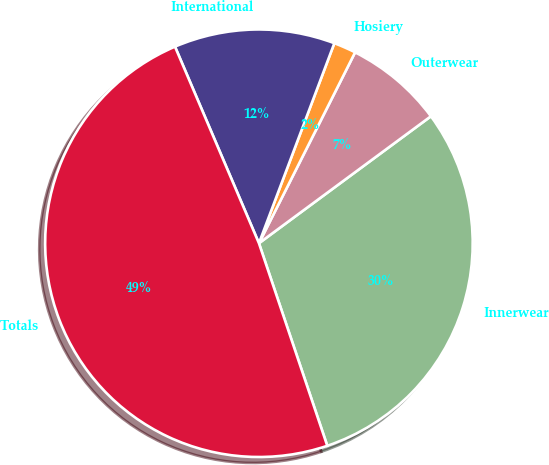Convert chart to OTSL. <chart><loc_0><loc_0><loc_500><loc_500><pie_chart><fcel>Innerwear<fcel>Outerwear<fcel>Hosiery<fcel>International<fcel>Totals<nl><fcel>29.94%<fcel>7.45%<fcel>1.69%<fcel>12.16%<fcel>48.75%<nl></chart> 